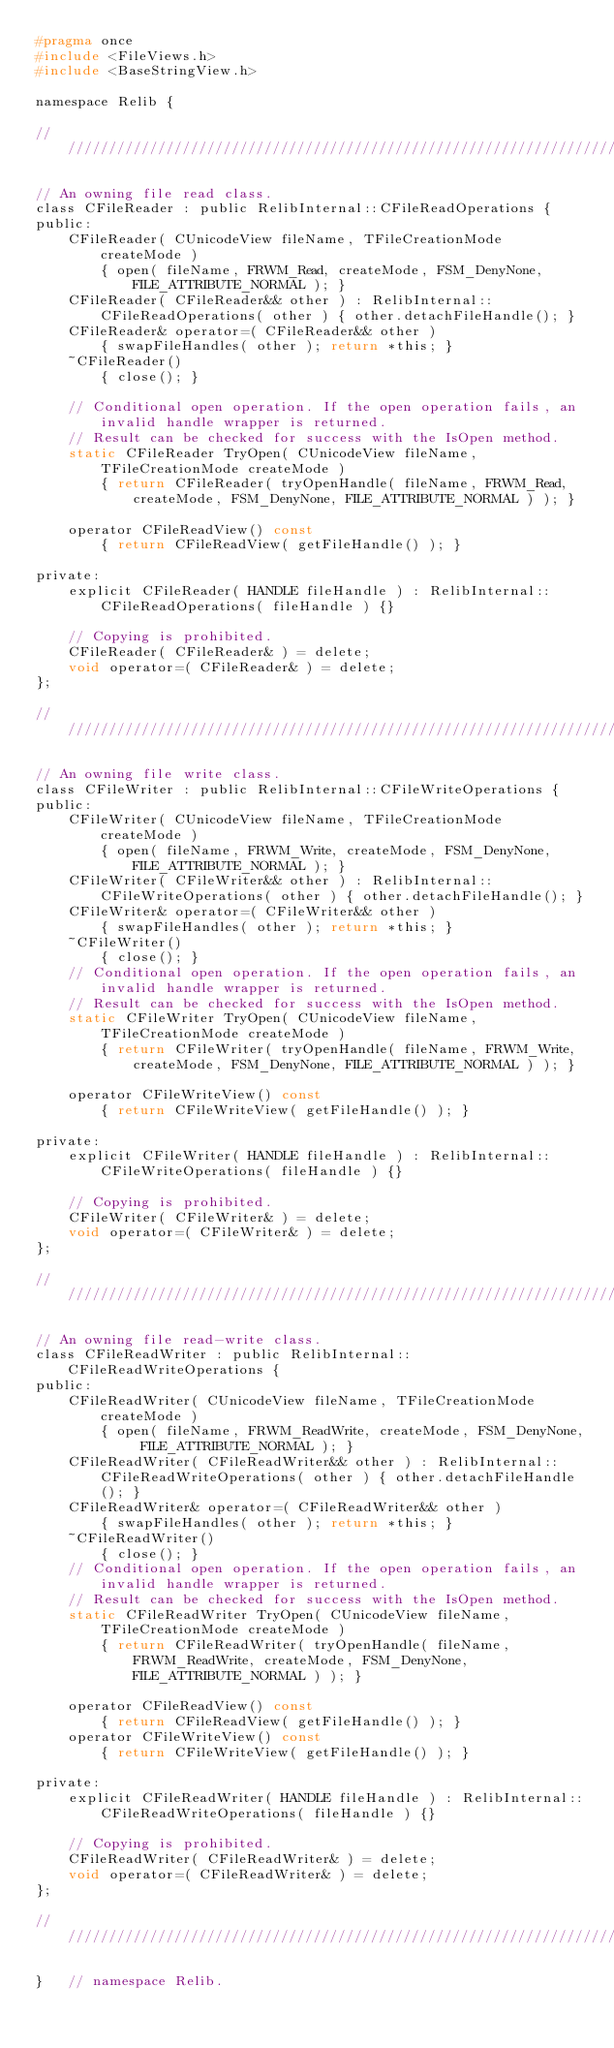<code> <loc_0><loc_0><loc_500><loc_500><_C_>#pragma once
#include <FileViews.h>
#include <BaseStringView.h>

namespace Relib {

//////////////////////////////////////////////////////////////////////////

// An owning file read class.
class CFileReader : public RelibInternal::CFileReadOperations {
public:
	CFileReader( CUnicodeView fileName, TFileCreationMode createMode )
		{ open( fileName, FRWM_Read, createMode, FSM_DenyNone, FILE_ATTRIBUTE_NORMAL ); }
	CFileReader( CFileReader&& other ) : RelibInternal::CFileReadOperations( other ) { other.detachFileHandle(); }
	CFileReader& operator=( CFileReader&& other )
		{ swapFileHandles( other ); return *this; }
	~CFileReader()
		{ close(); }

	// Conditional open operation. If the open operation fails, an invalid handle wrapper is returned.
	// Result can be checked for success with the IsOpen method.
	static CFileReader TryOpen( CUnicodeView fileName, TFileCreationMode createMode )
		{ return CFileReader( tryOpenHandle( fileName, FRWM_Read, createMode, FSM_DenyNone, FILE_ATTRIBUTE_NORMAL ) ); }

	operator CFileReadView() const
		{ return CFileReadView( getFileHandle() ); }

private:
	explicit CFileReader( HANDLE fileHandle ) : RelibInternal::CFileReadOperations( fileHandle ) {}

	// Copying is prohibited.
	CFileReader( CFileReader& ) = delete;
	void operator=( CFileReader& ) = delete;
};

//////////////////////////////////////////////////////////////////////////

// An owning file write class.
class CFileWriter : public RelibInternal::CFileWriteOperations {
public:
	CFileWriter( CUnicodeView fileName, TFileCreationMode createMode )
		{ open( fileName, FRWM_Write, createMode, FSM_DenyNone, FILE_ATTRIBUTE_NORMAL ); }
	CFileWriter( CFileWriter&& other ) : RelibInternal::CFileWriteOperations( other ) { other.detachFileHandle(); }
	CFileWriter& operator=( CFileWriter&& other )
		{ swapFileHandles( other ); return *this; }
	~CFileWriter()
		{ close(); }
	// Conditional open operation. If the open operation fails, an invalid handle wrapper is returned.
	// Result can be checked for success with the IsOpen method.
	static CFileWriter TryOpen( CUnicodeView fileName, TFileCreationMode createMode )
		{ return CFileWriter( tryOpenHandle( fileName, FRWM_Write, createMode, FSM_DenyNone, FILE_ATTRIBUTE_NORMAL ) ); }

	operator CFileWriteView() const
		{ return CFileWriteView( getFileHandle() ); }

private:
	explicit CFileWriter( HANDLE fileHandle ) : RelibInternal::CFileWriteOperations( fileHandle ) {}

	// Copying is prohibited.
	CFileWriter( CFileWriter& ) = delete;
	void operator=( CFileWriter& ) = delete;
};

//////////////////////////////////////////////////////////////////////////

// An owning file read-write class.
class CFileReadWriter : public RelibInternal::CFileReadWriteOperations {
public:
	CFileReadWriter( CUnicodeView fileName, TFileCreationMode createMode )
		{ open( fileName, FRWM_ReadWrite, createMode, FSM_DenyNone, FILE_ATTRIBUTE_NORMAL ); }
	CFileReadWriter( CFileReadWriter&& other ) : RelibInternal::CFileReadWriteOperations( other ) { other.detachFileHandle(); }
	CFileReadWriter& operator=( CFileReadWriter&& other )
		{ swapFileHandles( other ); return *this; }
	~CFileReadWriter()
		{ close(); }
	// Conditional open operation. If the open operation fails, an invalid handle wrapper is returned.
	// Result can be checked for success with the IsOpen method.
	static CFileReadWriter TryOpen( CUnicodeView fileName, TFileCreationMode createMode )
		{ return CFileReadWriter( tryOpenHandle( fileName, FRWM_ReadWrite, createMode, FSM_DenyNone, FILE_ATTRIBUTE_NORMAL ) ); }
	
	operator CFileReadView() const
		{ return CFileReadView( getFileHandle() ); }
	operator CFileWriteView() const
		{ return CFileWriteView( getFileHandle() ); }

private:
	explicit CFileReadWriter( HANDLE fileHandle ) : RelibInternal::CFileReadWriteOperations( fileHandle ) {}

	// Copying is prohibited.
	CFileReadWriter( CFileReadWriter& ) = delete;
	void operator=( CFileReadWriter& ) = delete;
};

//////////////////////////////////////////////////////////////////////////

}	// namespace Relib.

</code> 